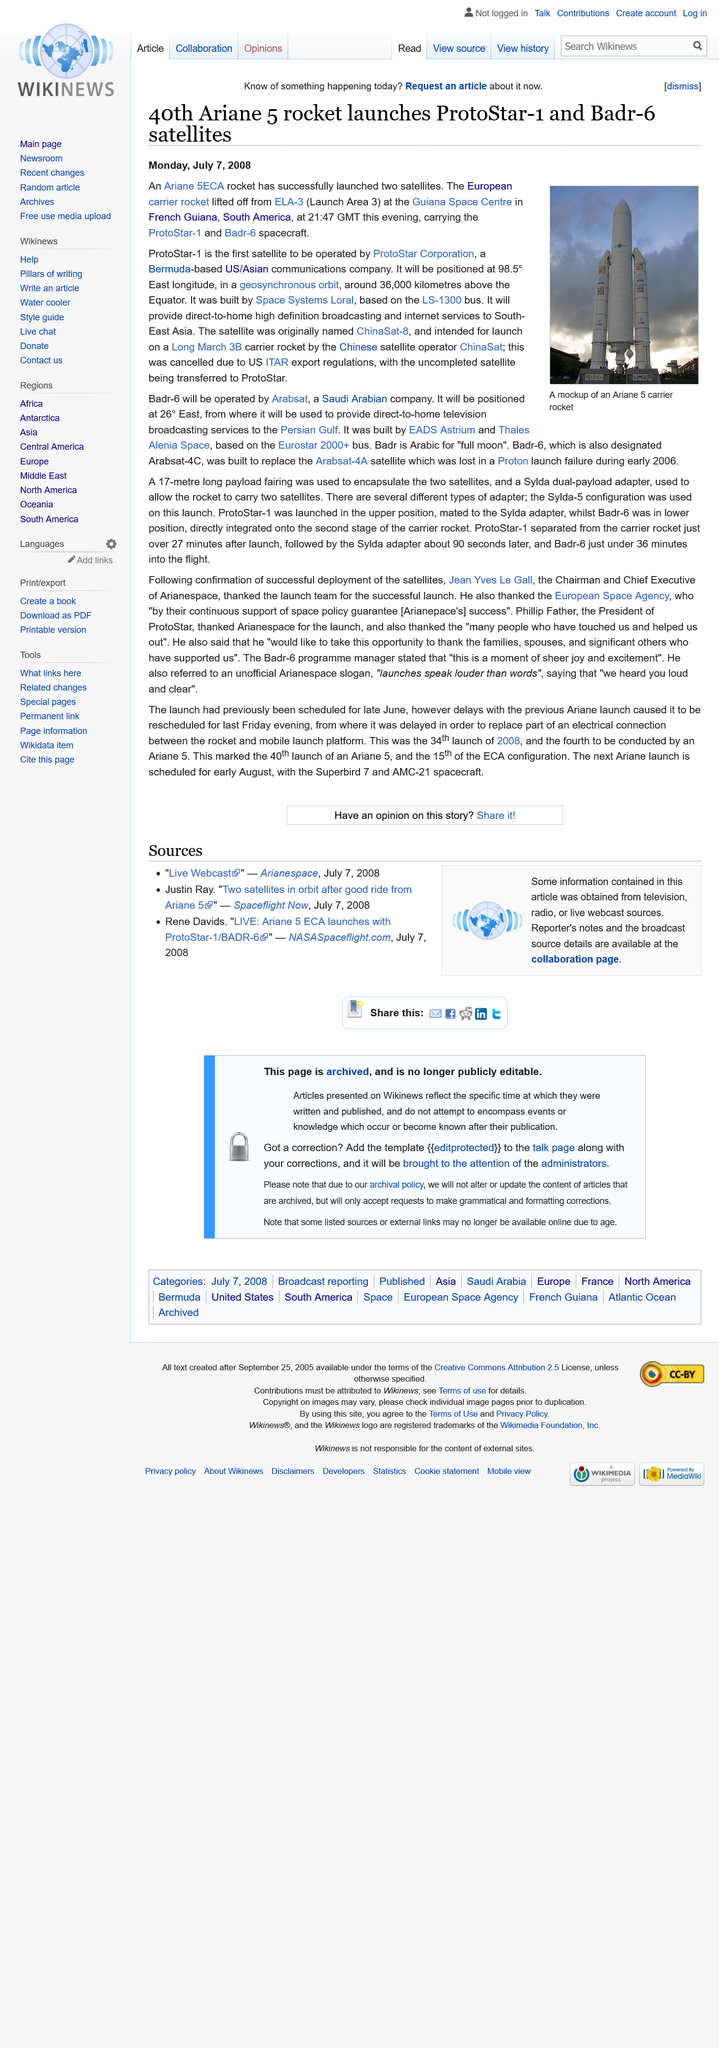Specify some key components in this picture. The rocket carried two spacecrafts, one of which was the first to be operated by ProtoStar Corporation. This pioneering achievement marked a significant milestone in the history of space exploration. The successful launch of two satellites by an Ariane 5ECA rocket has been declared. Alenia Space is a company that is based on the Eurostar 2000+ bus. 